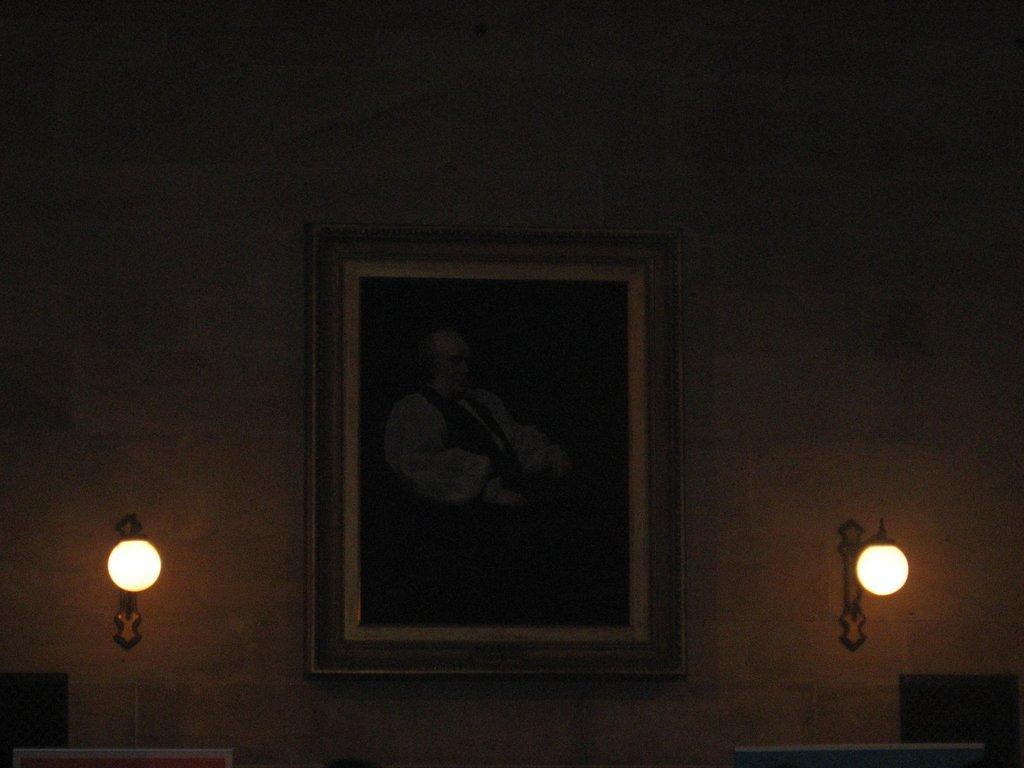Could you give a brief overview of what you see in this image? At the center of the image there is a photo frame on the wall. Beside the photo frame there are lights. 